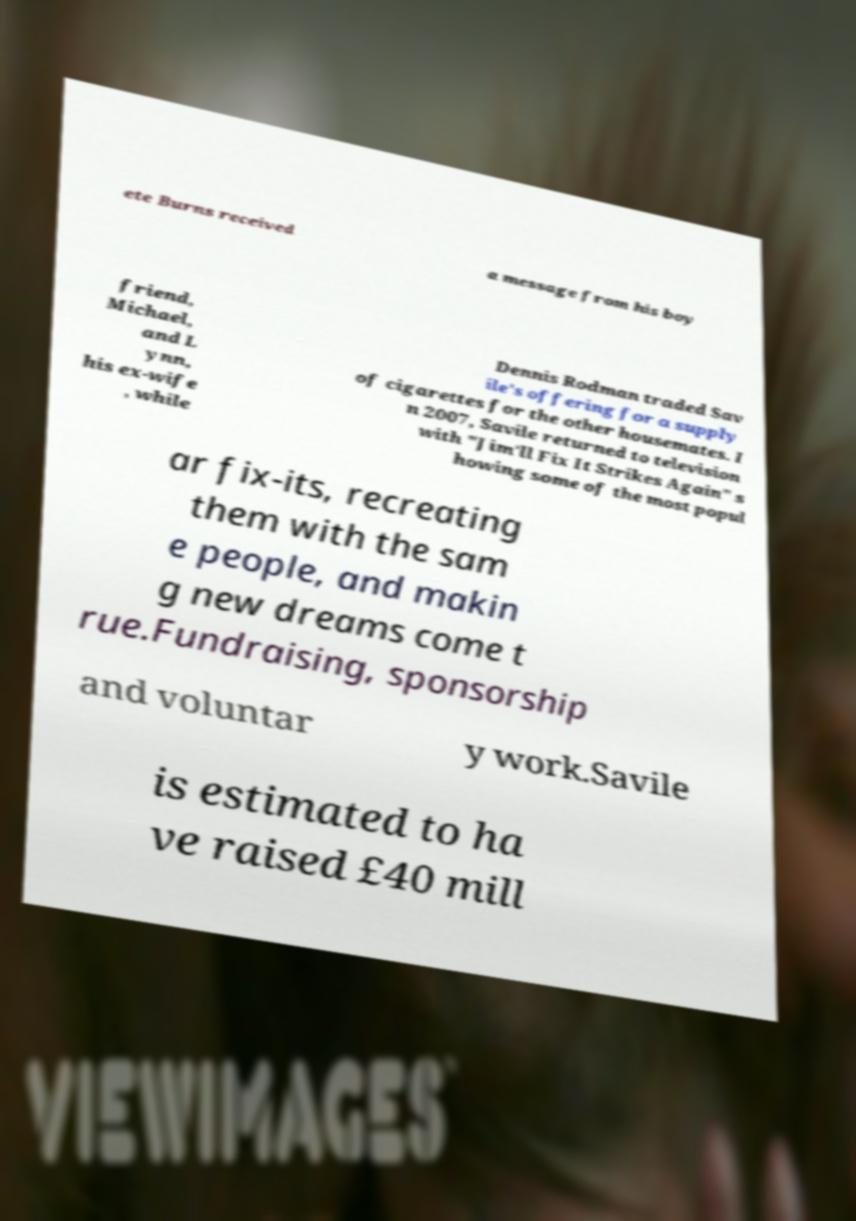Could you extract and type out the text from this image? ete Burns received a message from his boy friend, Michael, and L ynn, his ex-wife , while Dennis Rodman traded Sav ile's offering for a supply of cigarettes for the other housemates. I n 2007, Savile returned to television with "Jim'll Fix It Strikes Again" s howing some of the most popul ar fix-its, recreating them with the sam e people, and makin g new dreams come t rue.Fundraising, sponsorship and voluntar y work.Savile is estimated to ha ve raised £40 mill 